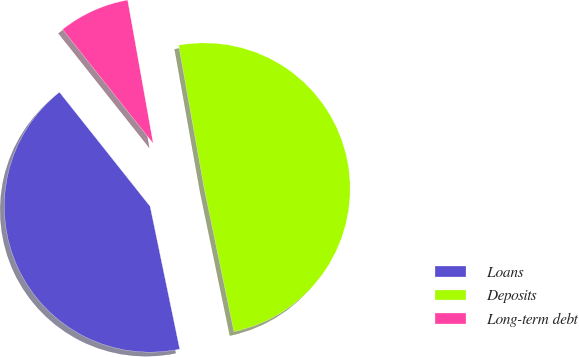Convert chart. <chart><loc_0><loc_0><loc_500><loc_500><pie_chart><fcel>Loans<fcel>Deposits<fcel>Long-term debt<nl><fcel>42.57%<fcel>49.55%<fcel>7.87%<nl></chart> 